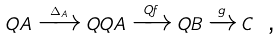Convert formula to latex. <formula><loc_0><loc_0><loc_500><loc_500>Q A \xrightarrow { \Delta _ { A } } Q Q A \xrightarrow { Q f } Q B \xrightarrow { g } C \ \text  ,</formula> 